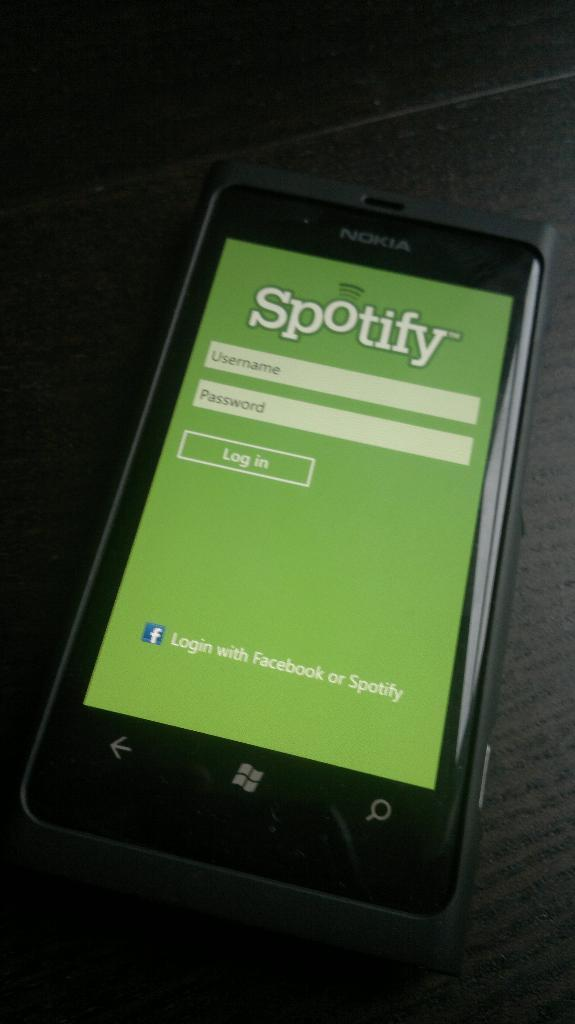What is the color of the surface in the image? The surface in the image is black. What is placed on the black surface? There is a mobile on the black surface. What logos can be seen on the mobile? The mobile has the logos of Facebook and Windows. Where are the scissors placed on the black surface in the image? There are no scissors present in the image. What type of bun is being held by the mobile in the image? There is no bun present in the image; it features a mobile with logos of Facebook and Windows. 